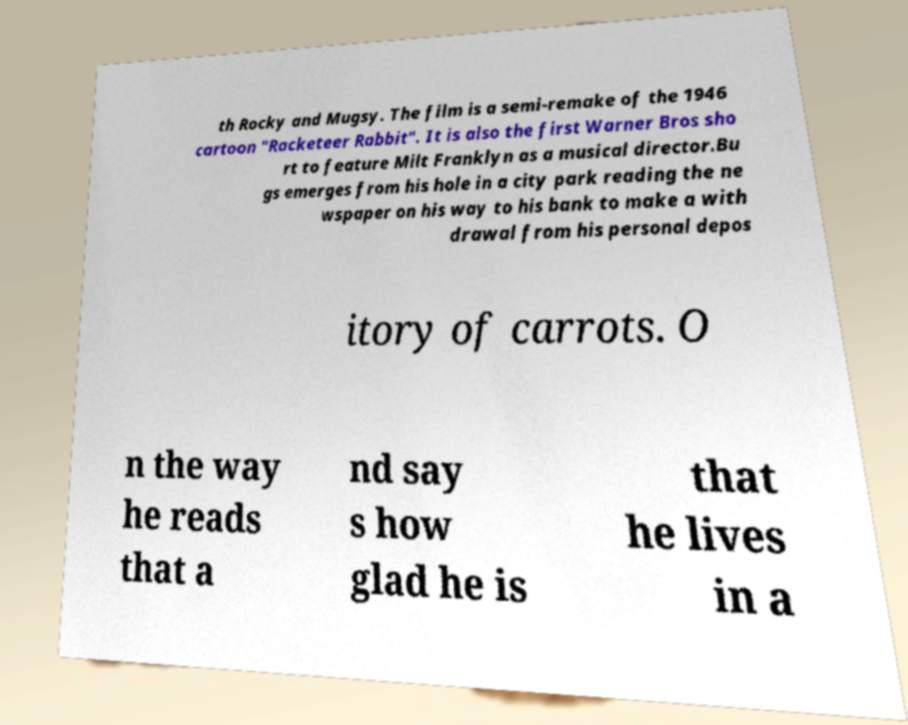Could you extract and type out the text from this image? th Rocky and Mugsy. The film is a semi-remake of the 1946 cartoon "Racketeer Rabbit". It is also the first Warner Bros sho rt to feature Milt Franklyn as a musical director.Bu gs emerges from his hole in a city park reading the ne wspaper on his way to his bank to make a with drawal from his personal depos itory of carrots. O n the way he reads that a nd say s how glad he is that he lives in a 